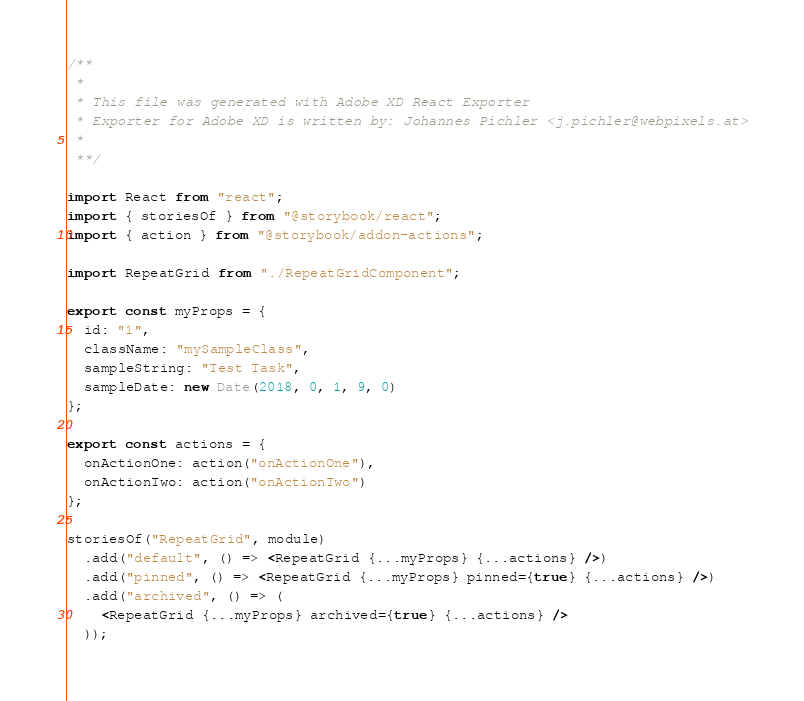<code> <loc_0><loc_0><loc_500><loc_500><_JavaScript_>/**
 *
 * This file was generated with Adobe XD React Exporter
 * Exporter for Adobe XD is written by: Johannes Pichler <j.pichler@webpixels.at>
 *
 **/

import React from "react";
import { storiesOf } from "@storybook/react";
import { action } from "@storybook/addon-actions";

import RepeatGrid from "./RepeatGridComponent";

export const myProps = {
  id: "1",
  className: "mySampleClass",
  sampleString: "Test Task",
  sampleDate: new Date(2018, 0, 1, 9, 0)
};

export const actions = {
  onActionOne: action("onActionOne"),
  onActionTwo: action("onActionTwo")
};

storiesOf("RepeatGrid", module)
  .add("default", () => <RepeatGrid {...myProps} {...actions} />)
  .add("pinned", () => <RepeatGrid {...myProps} pinned={true} {...actions} />)
  .add("archived", () => (
    <RepeatGrid {...myProps} archived={true} {...actions} />
  ));
</code> 